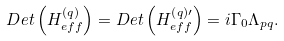<formula> <loc_0><loc_0><loc_500><loc_500>D e t \left ( H _ { e f f } ^ { \left ( q \right ) } \right ) = D e t \left ( H _ { e f f } ^ { \left ( q \right ) \prime } \right ) = i \Gamma _ { 0 } \Lambda _ { p q } .</formula> 